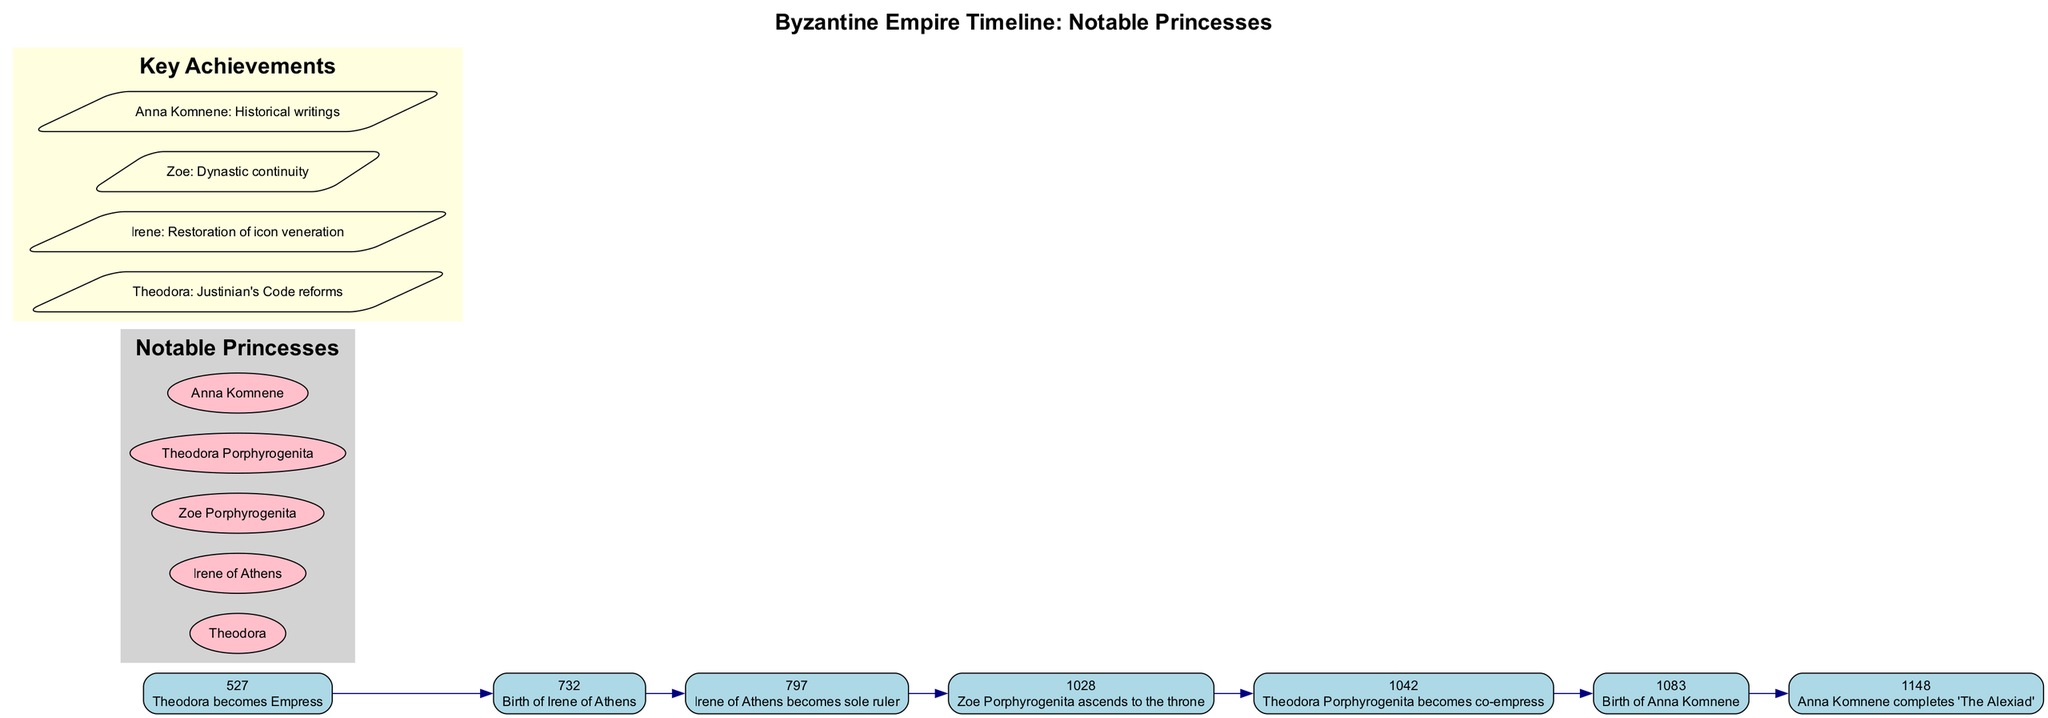What year did Theodora become Empress? The diagram shows that Theodora became Empress in the year 527, which is directly indicated next to the event in the timeline.
Answer: 527 What notable princess was born in 732? According to the timeline, Irene of Athens was born in 732, as indicated by that specific year and event.
Answer: Irene of Athens How many notable princesses are listed in the diagram? The diagram contains five notable princesses, as shown in the "Notable Princesses" section. Counting the names listed confirms this total.
Answer: 5 What key achievement is associated with Anna Komnene? The diagram specifies that Anna Komnene's key achievement is her historical writings, as stated in the "Key Achievements" section associated with her name.
Answer: Historical writings Which princess was co-empress in 1042? The timeline indicates that Theodora Porphyrogenita became co-empress in 1042, as highlighted in the event details.
Answer: Theodora Porphyrogenita What event marks the birth of Anna Komnene? The diagram specifically notes the year 1083 as the birth year for Anna Komnene, which is presented clearly in the timeline's events.
Answer: Birth of Anna Komnene What significant event occurred in 797? In the timeline, the event specified for the year 797 is that Irene of Athens became the sole ruler, as directly indicated next to that year.
Answer: Irene of Athens becomes sole ruler Which princess is linked to the restoration of icon veneration? The diagram indicates that Irene's key achievement is the restoration of icon veneration, found in the "Key Achievements" section corresponding to her name.
Answer: Irene What key event happened in 1028? According to the timeline, the event in 1028 is that Zoe Porphyrogenita ascended to the throne, as clearly marked next to that year.
Answer: Zoe Porphyrogenita ascends to the throne 